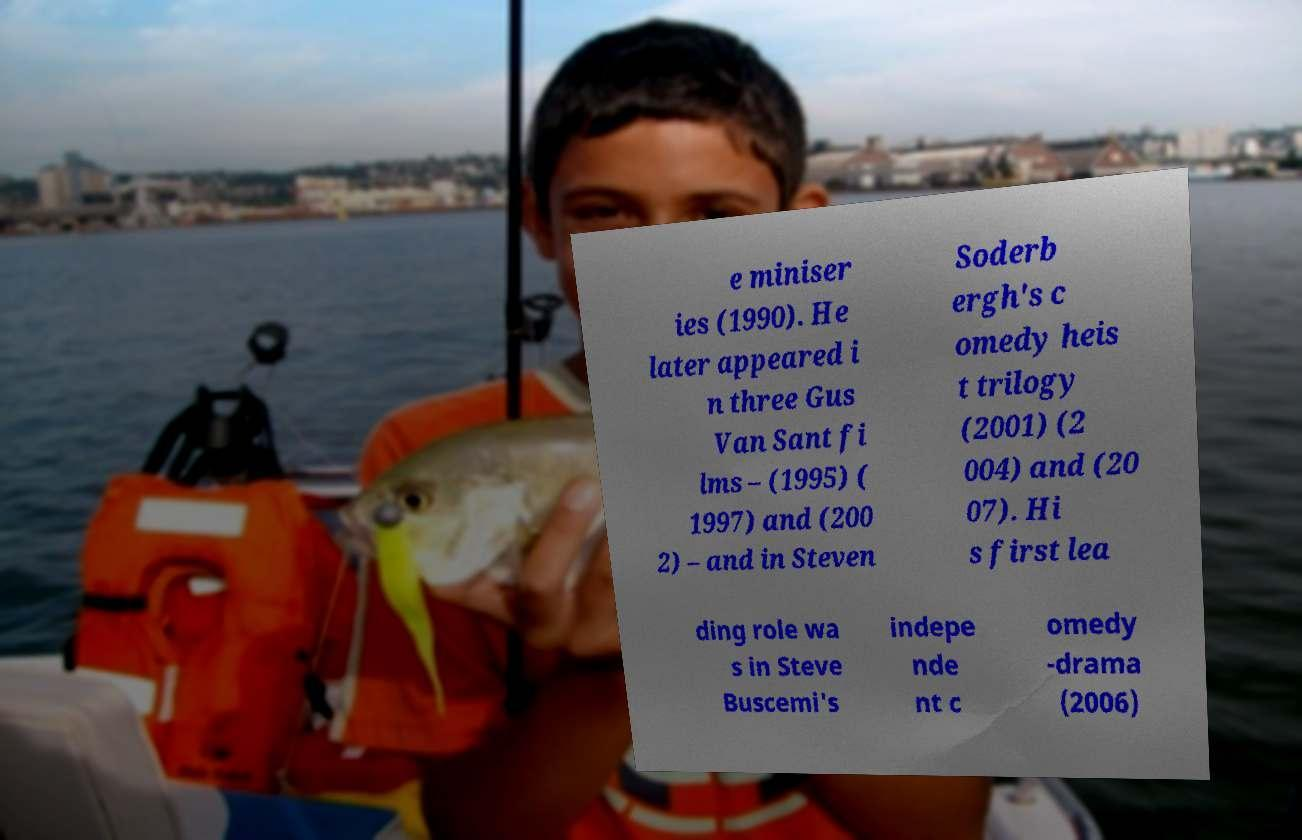I need the written content from this picture converted into text. Can you do that? e miniser ies (1990). He later appeared i n three Gus Van Sant fi lms – (1995) ( 1997) and (200 2) – and in Steven Soderb ergh's c omedy heis t trilogy (2001) (2 004) and (20 07). Hi s first lea ding role wa s in Steve Buscemi's indepe nde nt c omedy -drama (2006) 